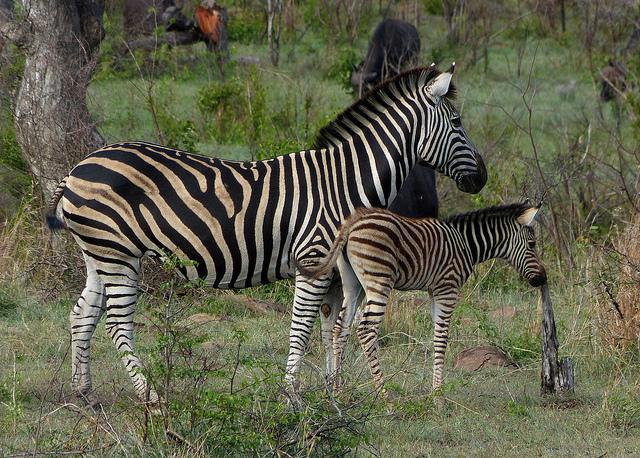Are the zebras all facing the same direction?
Write a very short answer. Yes. How are the animals related?
Concise answer only. Parent and child. How many zebras are in the picture?
Write a very short answer. 2. Is this on safari?
Answer briefly. Yes. Are the zebras in a zoo?
Keep it brief. No. Is this animal eating grass?
Short answer required. No. Are both animals adults?
Write a very short answer. No. Is the zebra on the left bigger or smaller than the one on the right?
Give a very brief answer. Bigger. 